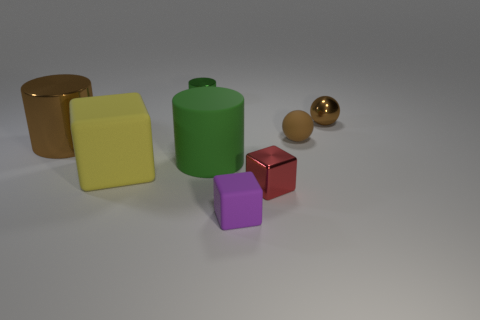Add 1 tiny red rubber spheres. How many objects exist? 9 Subtract all cylinders. How many objects are left? 5 Subtract all small red shiny cylinders. Subtract all small brown rubber balls. How many objects are left? 7 Add 3 tiny green shiny objects. How many tiny green shiny objects are left? 4 Add 5 green metallic blocks. How many green metallic blocks exist? 5 Subtract 0 purple cylinders. How many objects are left? 8 